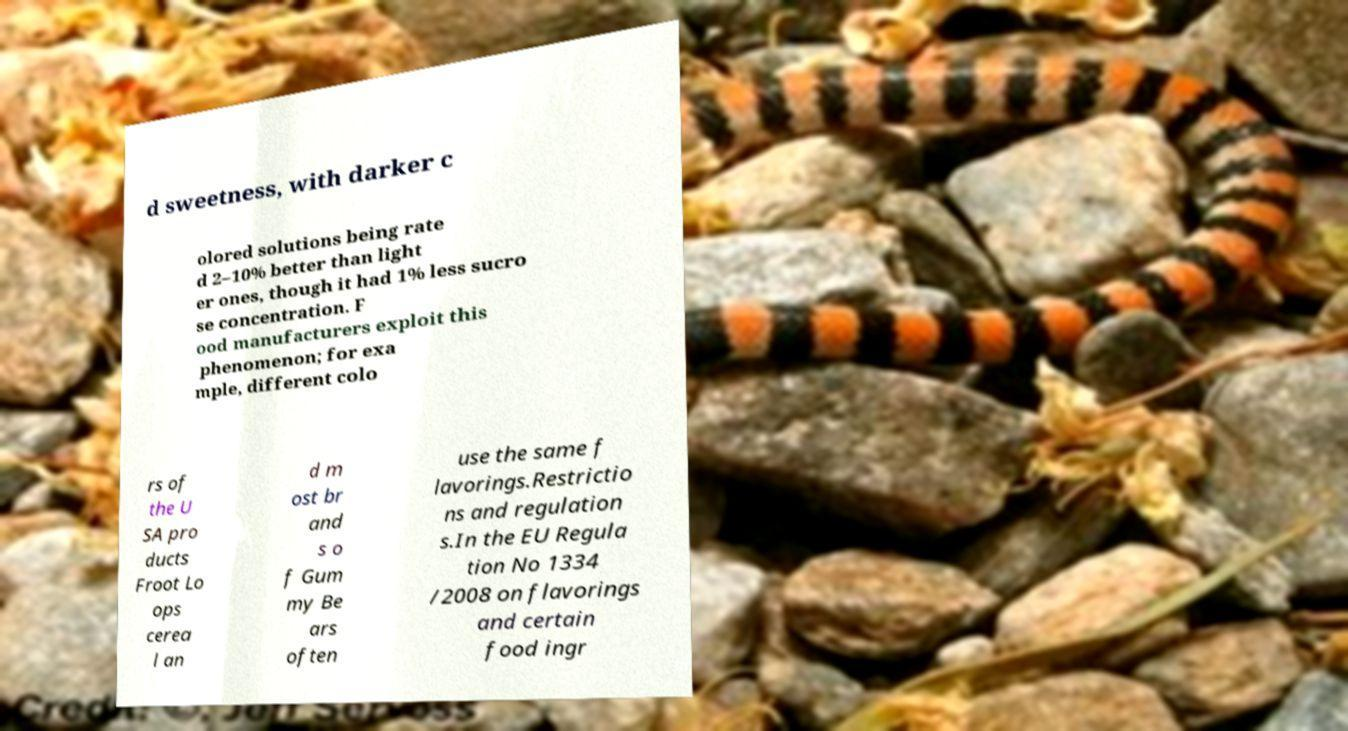Please read and relay the text visible in this image. What does it say? d sweetness, with darker c olored solutions being rate d 2–10% better than light er ones, though it had 1% less sucro se concentration. F ood manufacturers exploit this phenomenon; for exa mple, different colo rs of the U SA pro ducts Froot Lo ops cerea l an d m ost br and s o f Gum my Be ars often use the same f lavorings.Restrictio ns and regulation s.In the EU Regula tion No 1334 /2008 on flavorings and certain food ingr 